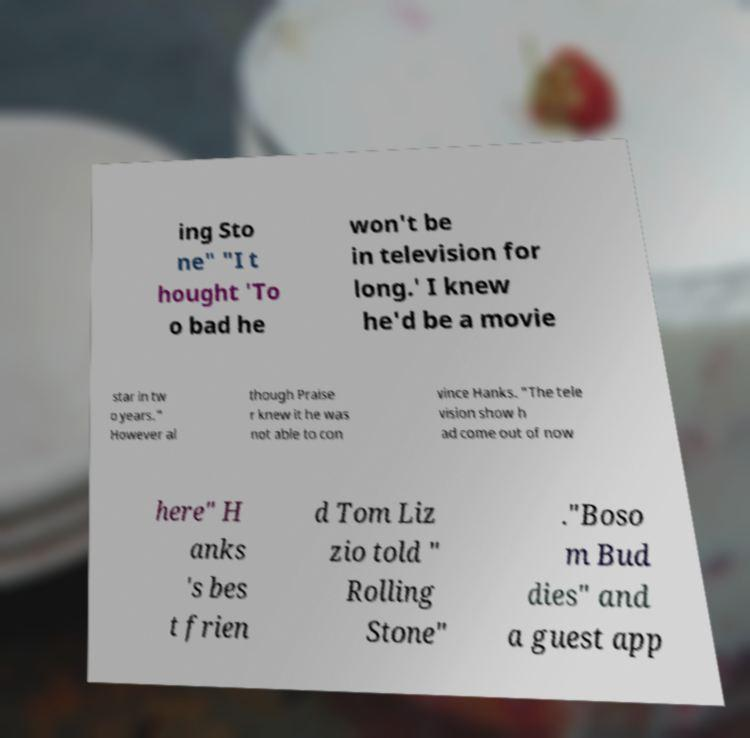Can you accurately transcribe the text from the provided image for me? ing Sto ne" "I t hought 'To o bad he won't be in television for long.' I knew he'd be a movie star in tw o years." However al though Praise r knew it he was not able to con vince Hanks. "The tele vision show h ad come out of now here" H anks 's bes t frien d Tom Liz zio told " Rolling Stone" ."Boso m Bud dies" and a guest app 